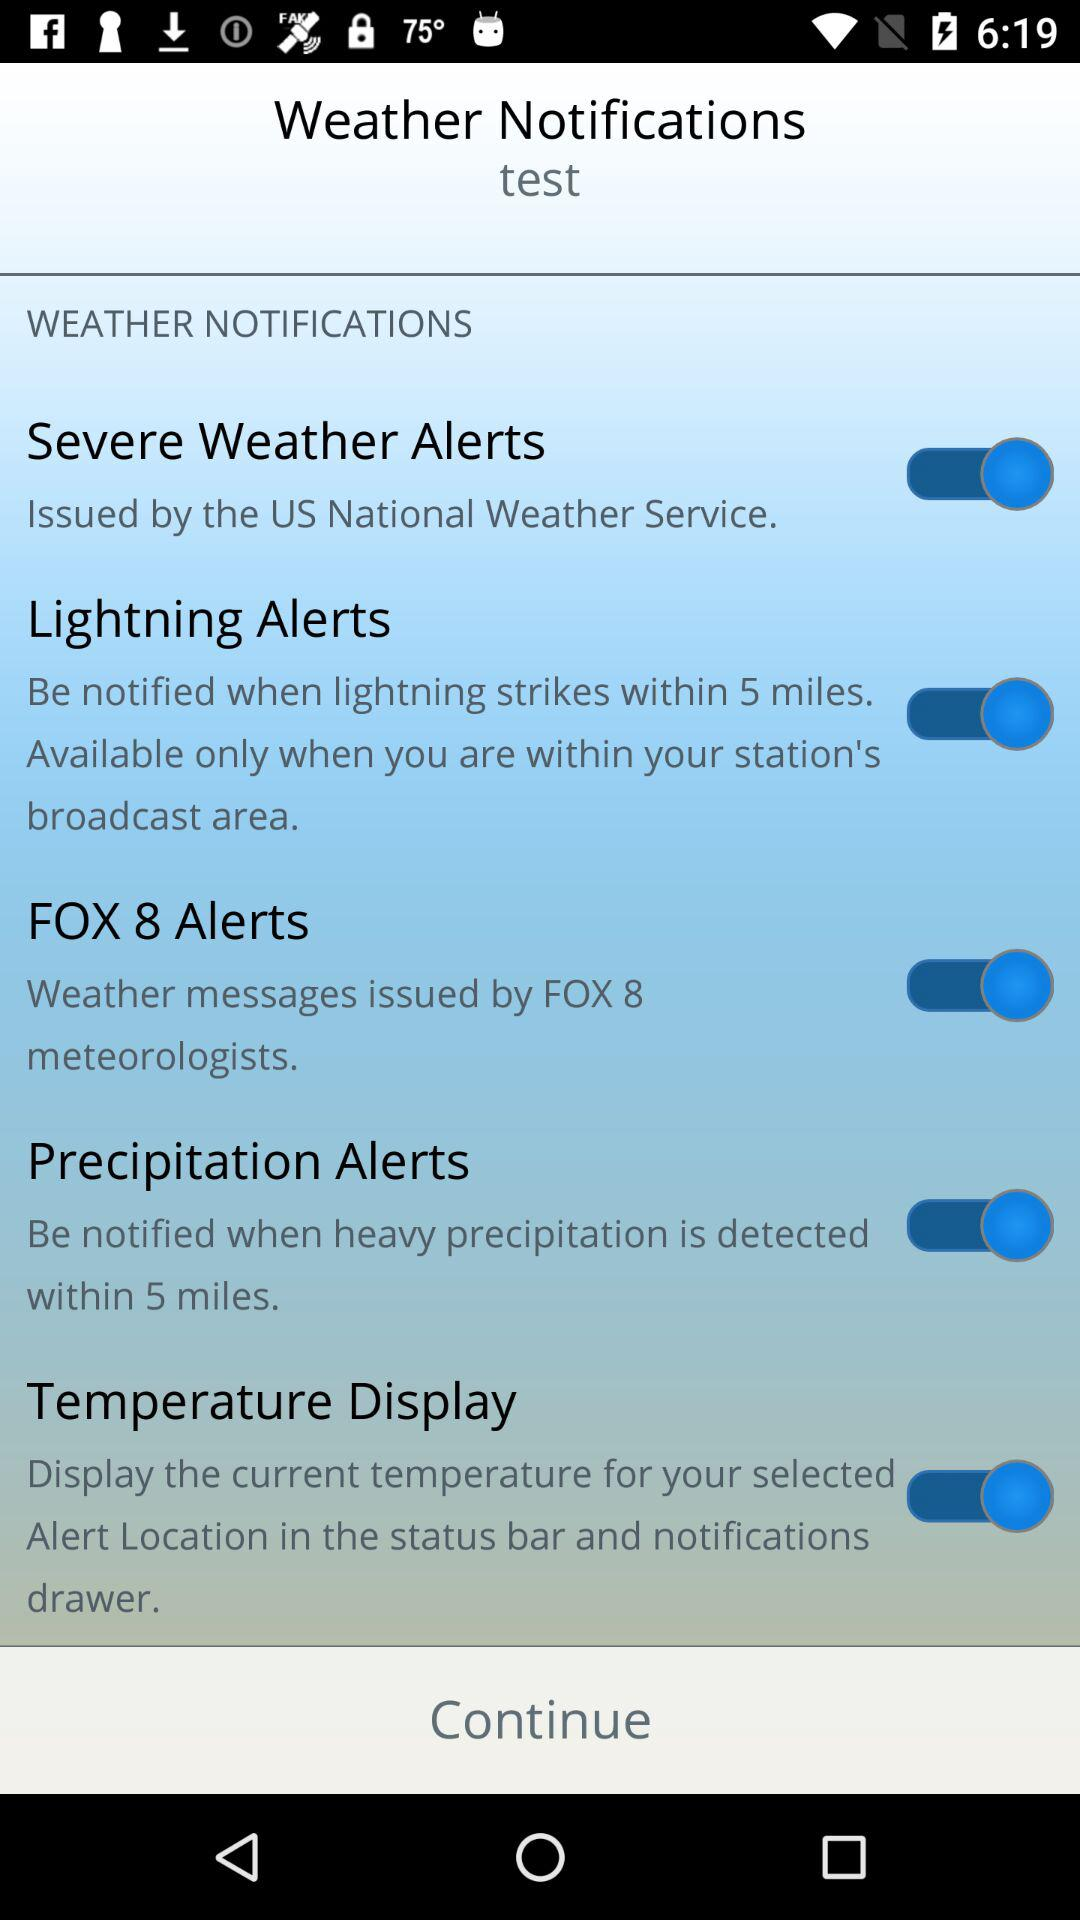What service issued severe weather alerts? The severe weather alerts were issued by the "US National Weather Service". 